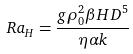<formula> <loc_0><loc_0><loc_500><loc_500>R a _ { H } = \frac { g \rho _ { 0 } ^ { 2 } \beta H D ^ { 5 } } { \eta \alpha k }</formula> 